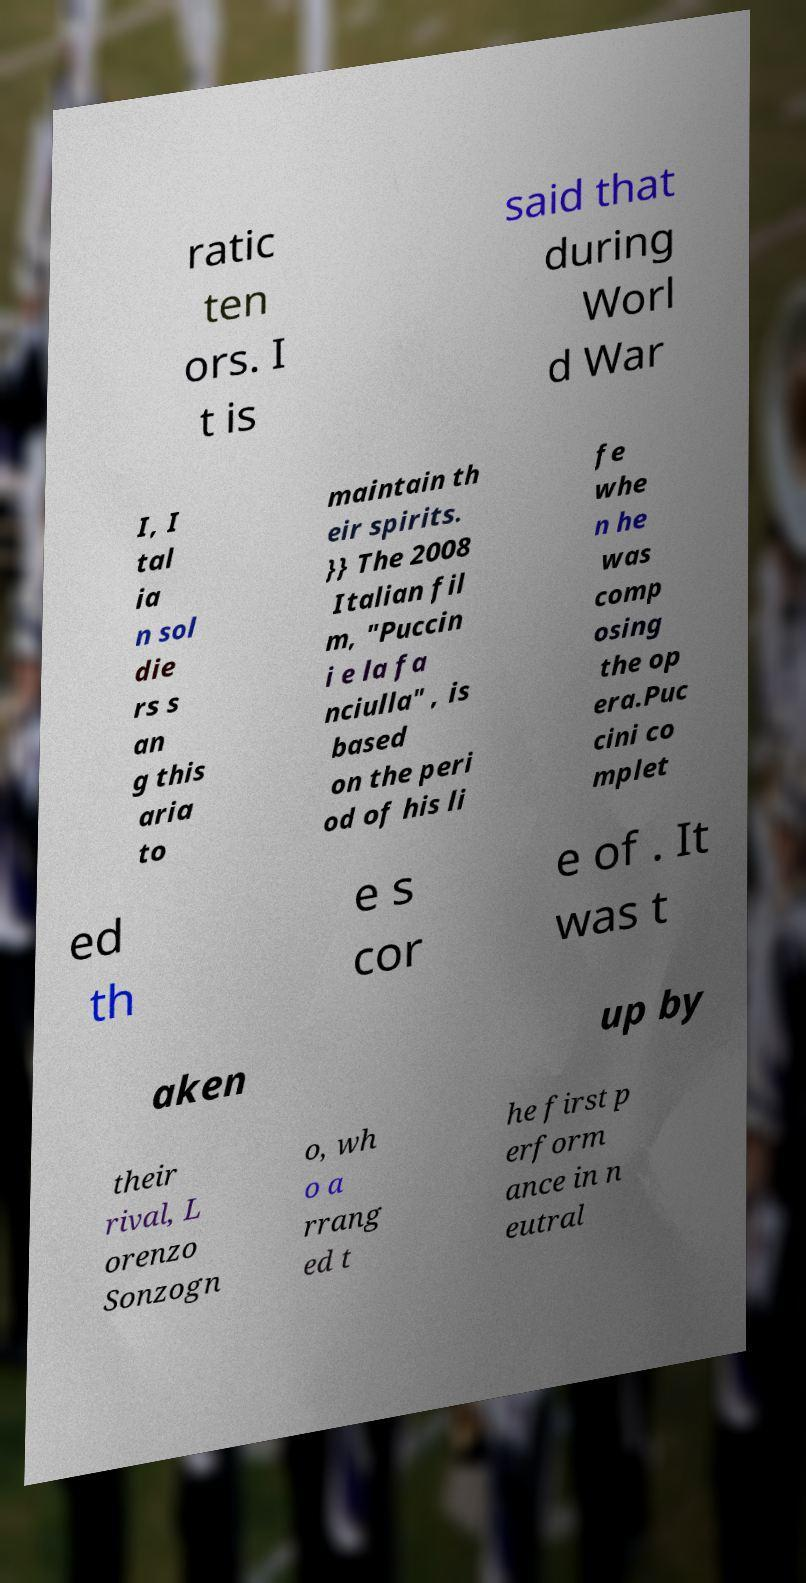There's text embedded in this image that I need extracted. Can you transcribe it verbatim? ratic ten ors. I t is said that during Worl d War I, I tal ia n sol die rs s an g this aria to maintain th eir spirits. }} The 2008 Italian fil m, "Puccin i e la fa nciulla" , is based on the peri od of his li fe whe n he was comp osing the op era.Puc cini co mplet ed th e s cor e of . It was t aken up by their rival, L orenzo Sonzogn o, wh o a rrang ed t he first p erform ance in n eutral 